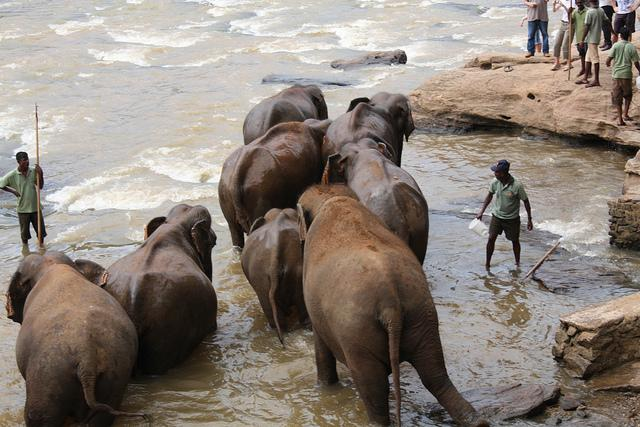Why is the person on the right of the elephants holding a bucket? Please explain your reasoning. help wash. The person on the right of the elephants has a bucket for washing. 